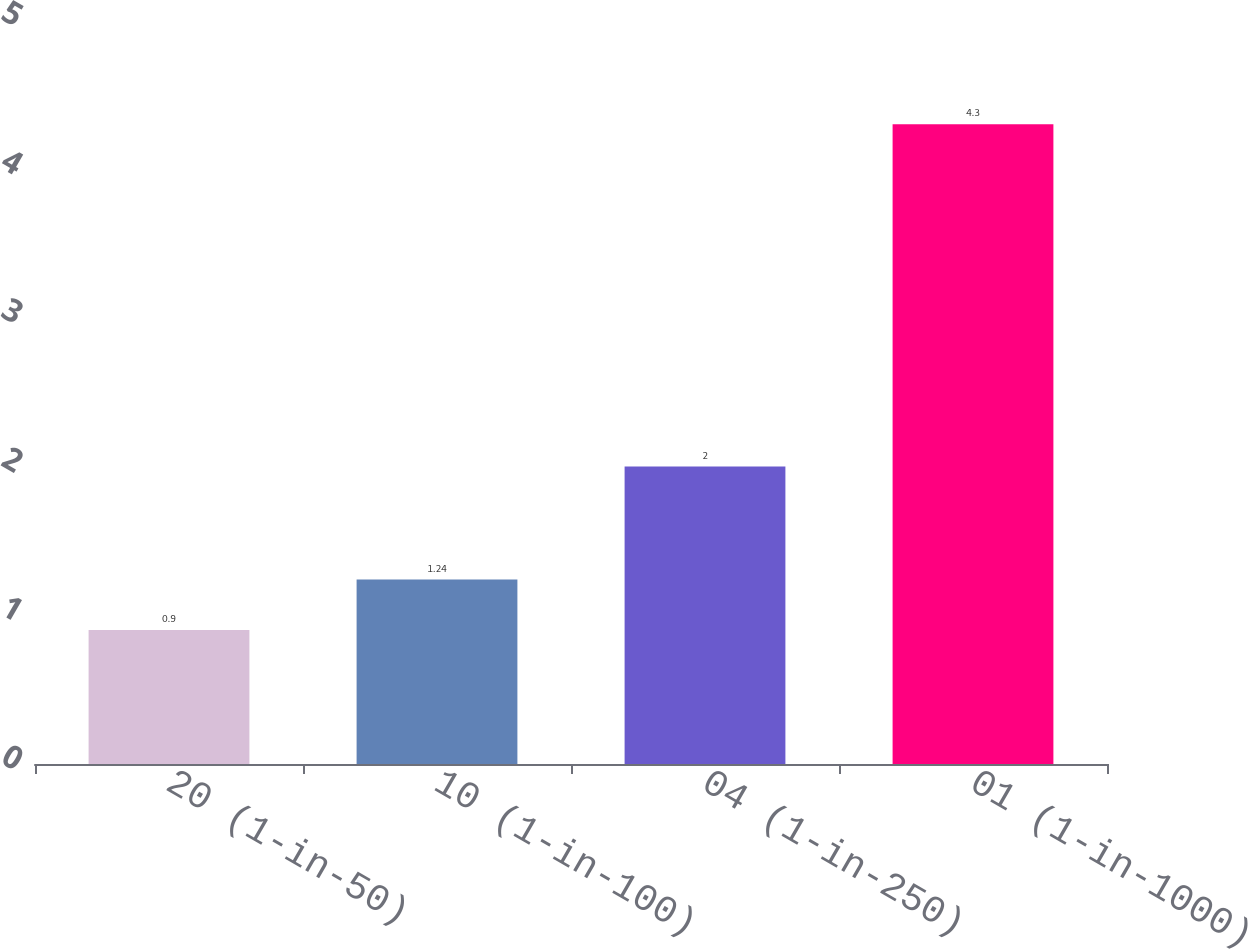<chart> <loc_0><loc_0><loc_500><loc_500><bar_chart><fcel>20 (1-in-50)<fcel>10 (1-in-100)<fcel>04 (1-in-250)<fcel>01 (1-in-1000)<nl><fcel>0.9<fcel>1.24<fcel>2<fcel>4.3<nl></chart> 